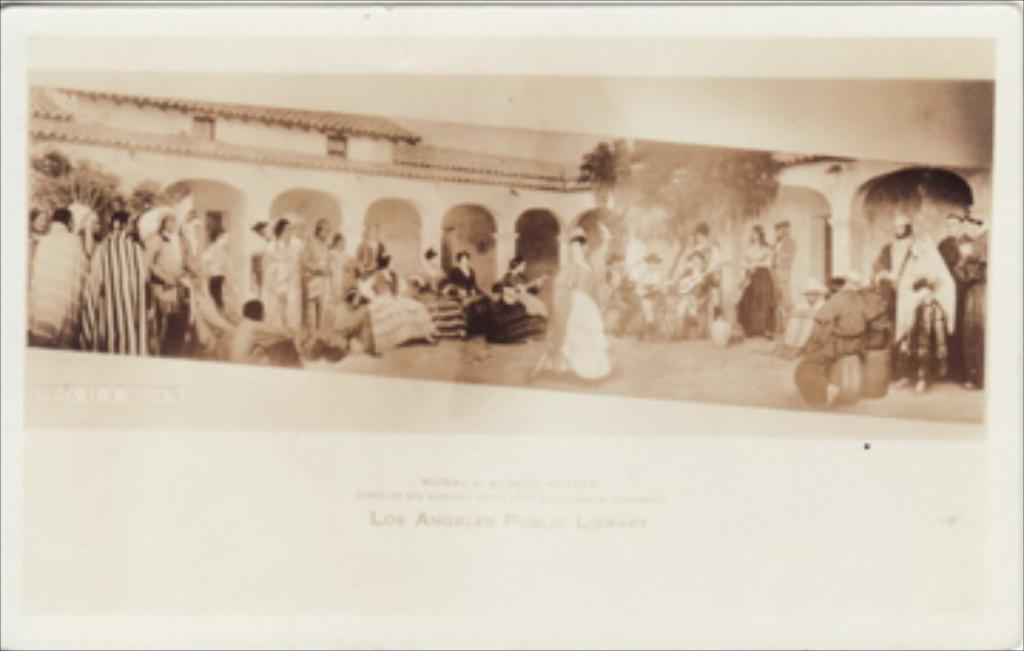What type of image is visible in the picture? There is an old photograph in the image. Who or what can be seen in the old photograph? There are people and a building in the old photograph. What other elements are present in the old photograph? There are trees and text in the old photograph. Where is the heart-shaped mailbox located in the image? There is no heart-shaped mailbox present in the image. What role does the father play in the old photograph? There is no mention of a father in the image, as the facts provided only mention people in general. 